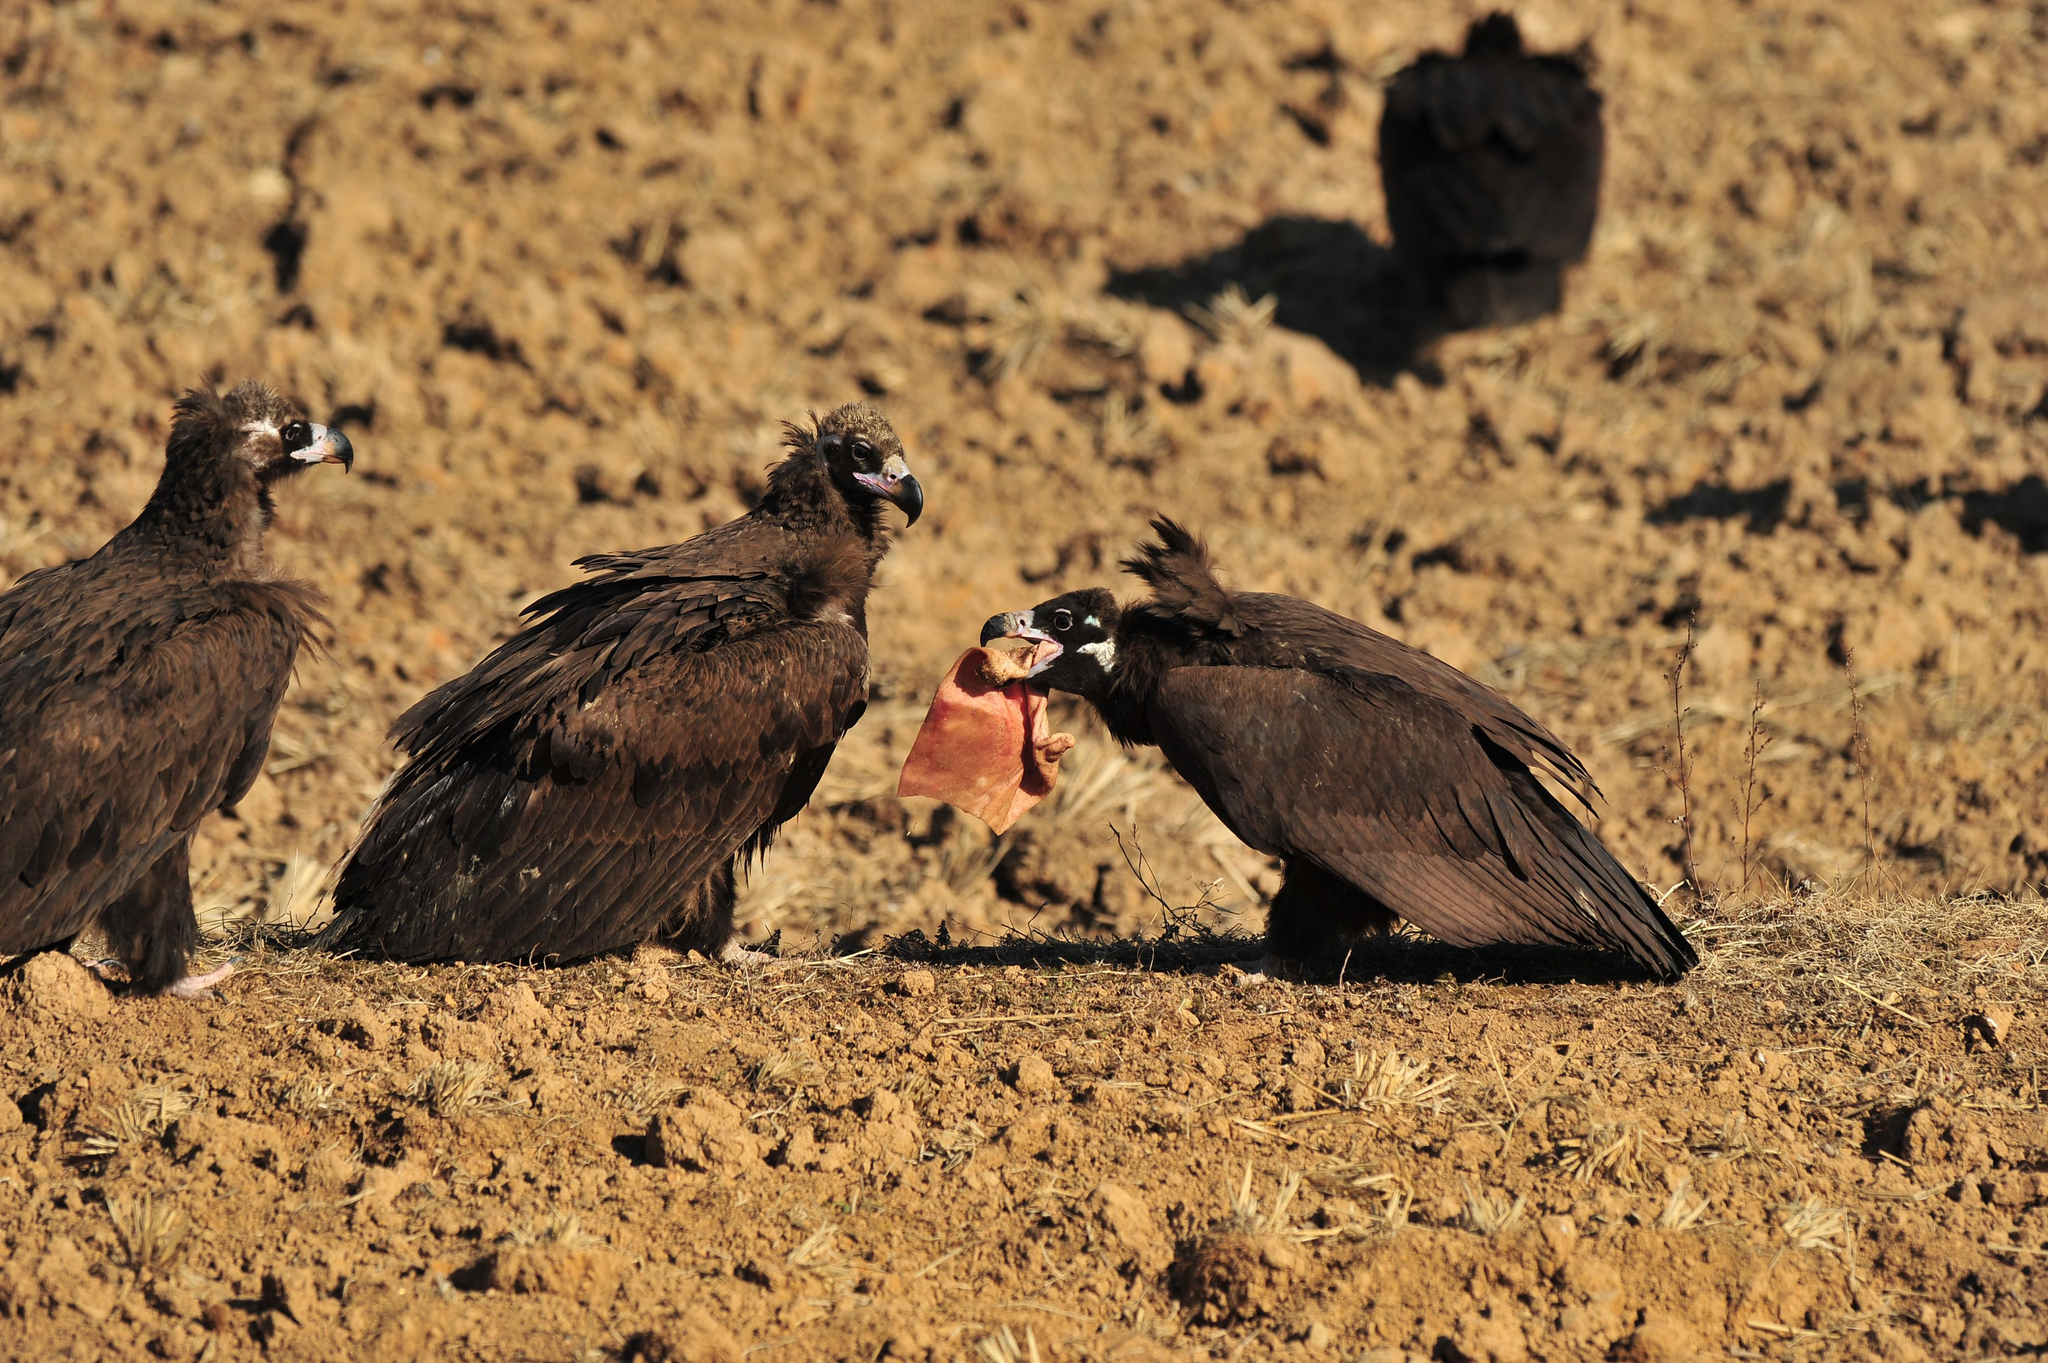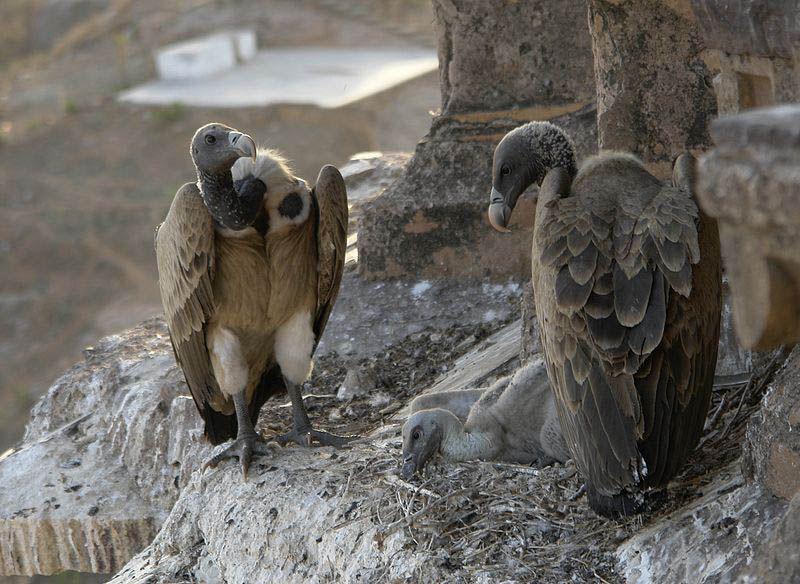The first image is the image on the left, the second image is the image on the right. Considering the images on both sides, is "The right image includes two vultures standing face-to-face." valid? Answer yes or no. Yes. The first image is the image on the left, the second image is the image on the right. Assess this claim about the two images: "In the image to the right, two vultures rest, wings closed.". Correct or not? Answer yes or no. Yes. 